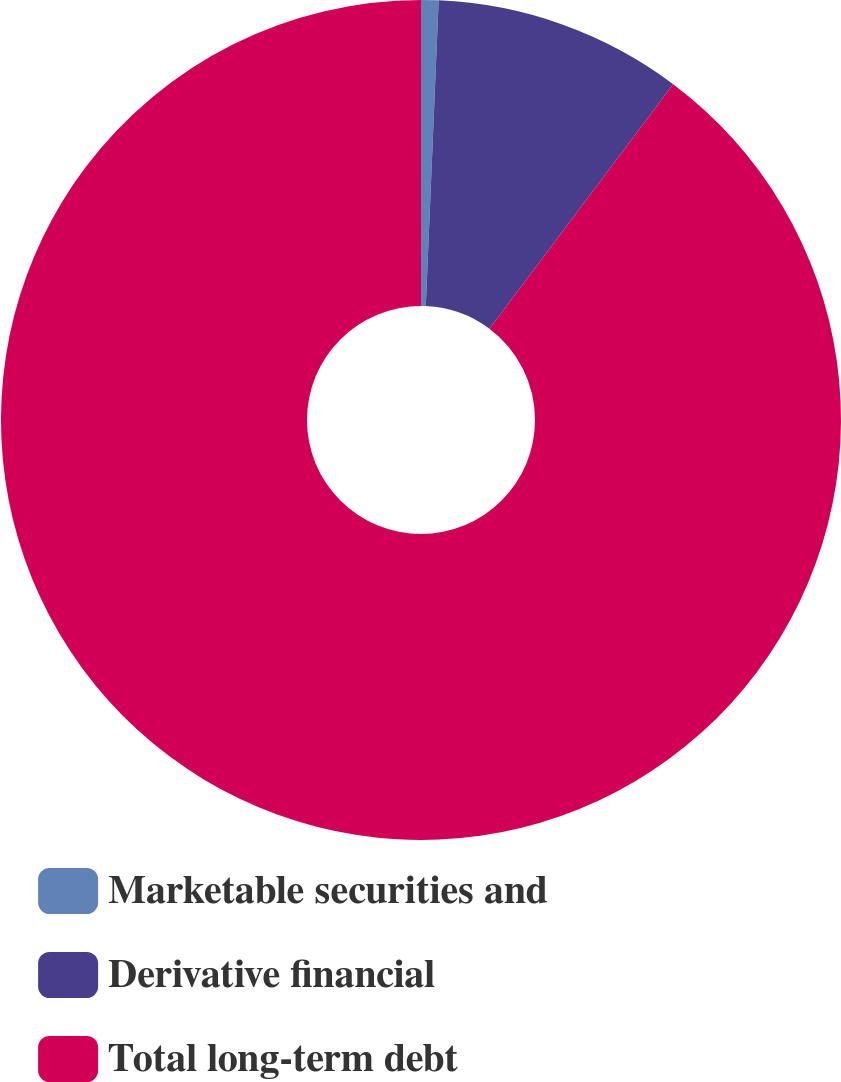Convert chart. <chart><loc_0><loc_0><loc_500><loc_500><pie_chart><fcel>Marketable securities and<fcel>Derivative financial<fcel>Total long-term debt<nl><fcel>0.67%<fcel>9.58%<fcel>89.75%<nl></chart> 